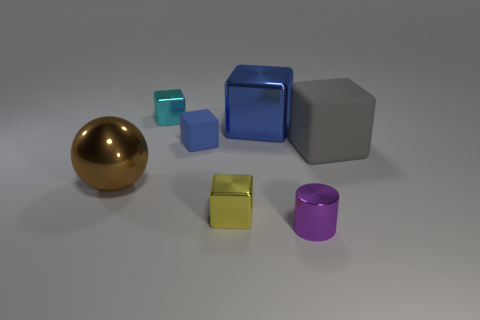Subtract all yellow cubes. How many cubes are left? 4 Add 3 small gray objects. How many objects exist? 10 Subtract all gray cubes. How many cubes are left? 4 Subtract all cubes. How many objects are left? 2 Subtract all big brown metal things. Subtract all cyan blocks. How many objects are left? 5 Add 1 tiny yellow blocks. How many tiny yellow blocks are left? 2 Add 6 large blue rubber blocks. How many large blue rubber blocks exist? 6 Subtract 1 purple cylinders. How many objects are left? 6 Subtract 1 cylinders. How many cylinders are left? 0 Subtract all yellow balls. Subtract all gray cubes. How many balls are left? 1 